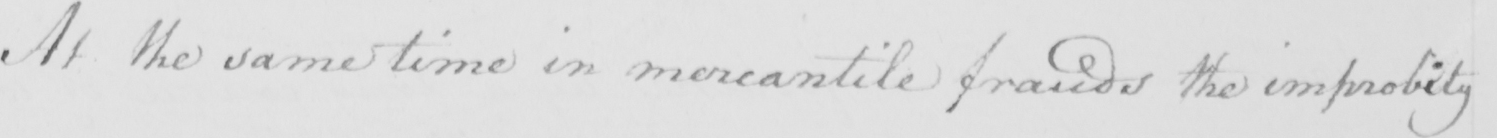Please provide the text content of this handwritten line. At the same time in mercantile frauds the improbity 